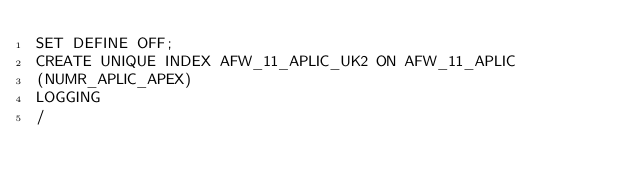Convert code to text. <code><loc_0><loc_0><loc_500><loc_500><_SQL_>SET DEFINE OFF;
CREATE UNIQUE INDEX AFW_11_APLIC_UK2 ON AFW_11_APLIC
(NUMR_APLIC_APEX)
LOGGING
/
</code> 